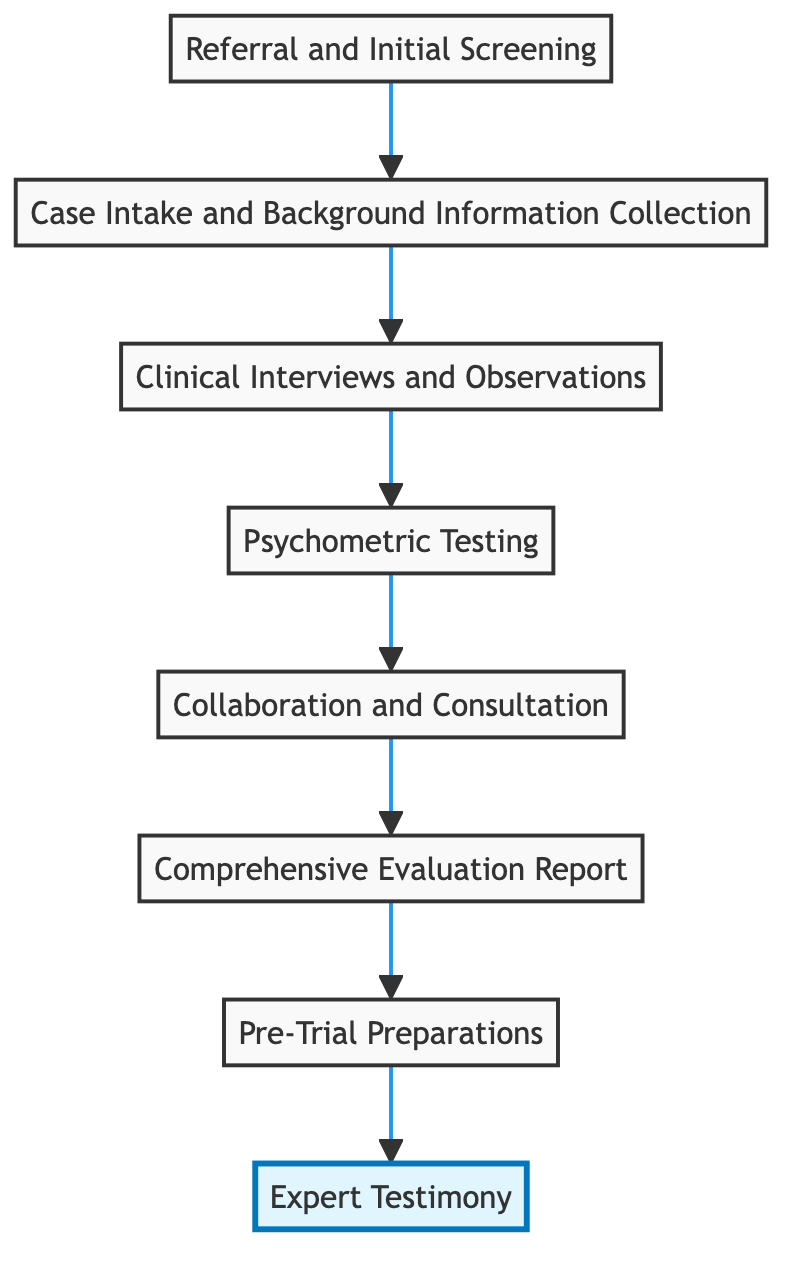What is the first step in the legal process journey? The first step, indicated at the bottom of the flow chart, is "Referral and Initial Screening." This is clearly labeled as the starting point of the process.
Answer: Referral and Initial Screening How many total steps are in the diagram? By counting all the nodes listed in the flow chart, we find there are eight steps in total, as represented from the referral to expert testimony.
Answer: 8 What is the last step before Expert Testimony? The step just before "Expert Testimony" is "Pre-Trial Preparations," which is shown directly above it, indicating it is the prior stage in the evaluation process.
Answer: Pre-Trial Preparations What type of testing occurs at level 4? At level 4, the diagram describes the process as "Psychometric Testing," specifically focusing on standardized psychological assessments.
Answer: Psychometric Testing Which steps involve collaboration with other specialists? "Collaboration and Consultation," which is at level 5, specifically mentions consulting with child psychologists and other specialists for comprehensive insights, indicating that neighboring steps focus on gathering external opinions.
Answer: Collaboration and Consultation Which step involves gathering background information? "Case Intake and Background Information Collection," located at level 2, is dedicated to collecting essential details regarding the child's medical, psychological, and social history.
Answer: Case Intake and Background Information Collection How is the Comprehensive Evaluation Report related to the prior steps? The "Comprehensive Evaluation Report" at level 6 is built upon the findings from the previous steps, such as clinical interviews, observations, and psychometric testing, indicating it serves as a summary and synthesis of the gathered information.
Answer: Comprehensive Evaluation Report What step comes immediately after Clinical Interviews? After "Clinical Interviews and Observations" at level 3, the next step according to the flow is "Psychometric Testing," showing the logical progression in the evaluation process.
Answer: Psychometric Testing What is the goal of the process according to the final step? The ultimate goal, represented by the final step "Expert Testimony," emphasizes the provision of expert witness testimony in court, showcasing the culmination of the entire evaluation process.
Answer: Expert Testimony 